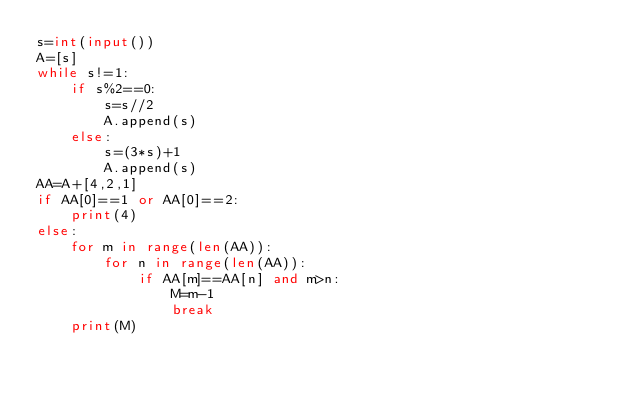Convert code to text. <code><loc_0><loc_0><loc_500><loc_500><_Python_>s=int(input())
A=[s]
while s!=1:
    if s%2==0:
        s=s//2
        A.append(s)
    else:
        s=(3*s)+1
        A.append(s)
AA=A+[4,2,1]
if AA[0]==1 or AA[0]==2:
    print(4)
else:
    for m in range(len(AA)):
        for n in range(len(AA)):
            if AA[m]==AA[n] and m>n:
                M=m-1
                break
    print(M)</code> 